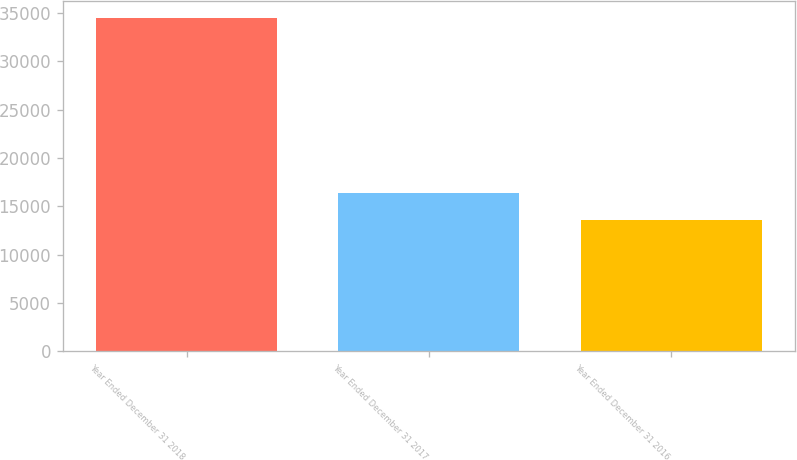Convert chart. <chart><loc_0><loc_0><loc_500><loc_500><bar_chart><fcel>Year Ended December 31 2018<fcel>Year Ended December 31 2017<fcel>Year Ended December 31 2016<nl><fcel>34479<fcel>16381<fcel>13619<nl></chart> 